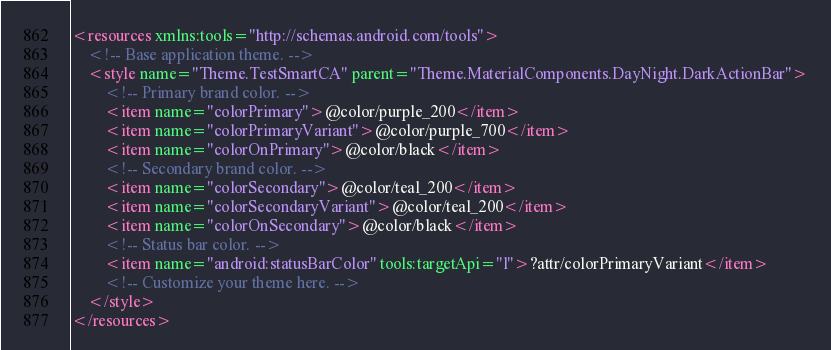<code> <loc_0><loc_0><loc_500><loc_500><_XML_><resources xmlns:tools="http://schemas.android.com/tools">
    <!-- Base application theme. -->
    <style name="Theme.TestSmartCA" parent="Theme.MaterialComponents.DayNight.DarkActionBar">
        <!-- Primary brand color. -->
        <item name="colorPrimary">@color/purple_200</item>
        <item name="colorPrimaryVariant">@color/purple_700</item>
        <item name="colorOnPrimary">@color/black</item>
        <!-- Secondary brand color. -->
        <item name="colorSecondary">@color/teal_200</item>
        <item name="colorSecondaryVariant">@color/teal_200</item>
        <item name="colorOnSecondary">@color/black</item>
        <!-- Status bar color. -->
        <item name="android:statusBarColor" tools:targetApi="l">?attr/colorPrimaryVariant</item>
        <!-- Customize your theme here. -->
    </style>
</resources></code> 